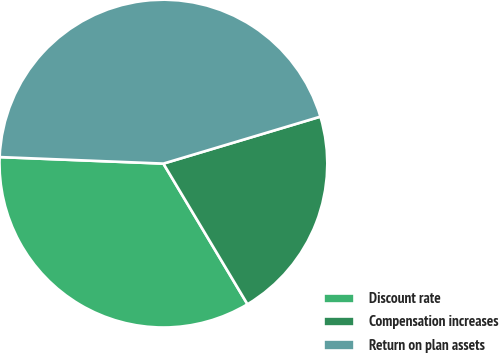Convert chart to OTSL. <chart><loc_0><loc_0><loc_500><loc_500><pie_chart><fcel>Discount rate<fcel>Compensation increases<fcel>Return on plan assets<nl><fcel>34.21%<fcel>21.05%<fcel>44.74%<nl></chart> 